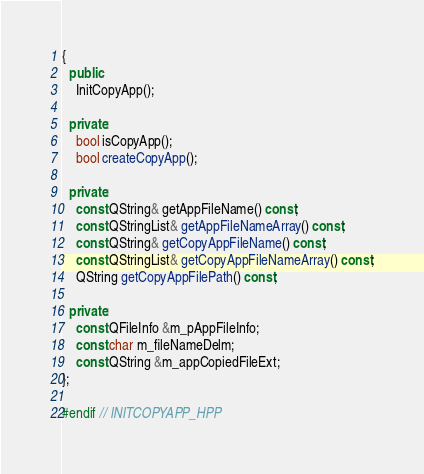Convert code to text. <code><loc_0><loc_0><loc_500><loc_500><_C++_>{
  public:
    InitCopyApp();

  private:
    bool isCopyApp();
    bool createCopyApp();

  private:
    const QString& getAppFileName() const;
    const QStringList& getAppFileNameArray() const;
    const QString& getCopyAppFileName() const;
    const QStringList& getCopyAppFileNameArray() const;
    QString getCopyAppFilePath() const;

  private:
    const QFileInfo &m_pAppFileInfo;
    const char m_fileNameDelm;
    const QString &m_appCopiedFileExt;
};

#endif // INITCOPYAPP_HPP
</code> 